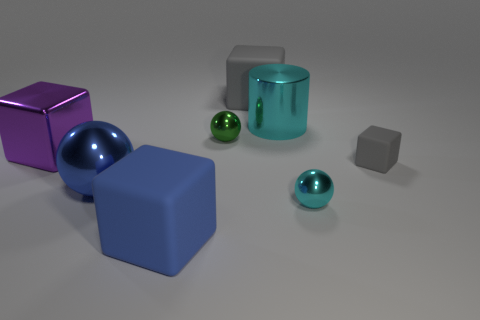Subtract all brown blocks. Subtract all blue balls. How many blocks are left? 4 Add 1 small brown metal objects. How many objects exist? 9 Subtract all cylinders. How many objects are left? 7 Add 5 tiny things. How many tiny things are left? 8 Add 5 large purple metal blocks. How many large purple metal blocks exist? 6 Subtract 0 red spheres. How many objects are left? 8 Subtract all blue rubber spheres. Subtract all big cyan cylinders. How many objects are left? 7 